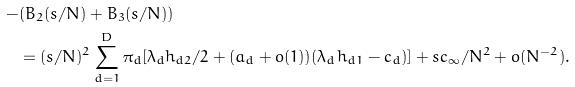<formula> <loc_0><loc_0><loc_500><loc_500>- & ( B _ { 2 } ( s / N ) + B _ { 3 } ( s / N ) ) \\ & = ( s / N ) ^ { 2 } \sum _ { d = 1 } ^ { D } \pi _ { d } [ \lambda _ { d } h _ { d 2 } / 2 + ( a _ { d } + o ( 1 ) ) ( \lambda _ { d } h _ { d 1 } - c _ { d } ) ] + s c _ { \infty } / N ^ { 2 } + o ( N ^ { - 2 } ) .</formula> 